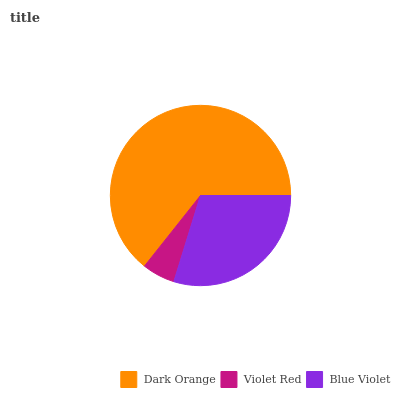Is Violet Red the minimum?
Answer yes or no. Yes. Is Dark Orange the maximum?
Answer yes or no. Yes. Is Blue Violet the minimum?
Answer yes or no. No. Is Blue Violet the maximum?
Answer yes or no. No. Is Blue Violet greater than Violet Red?
Answer yes or no. Yes. Is Violet Red less than Blue Violet?
Answer yes or no. Yes. Is Violet Red greater than Blue Violet?
Answer yes or no. No. Is Blue Violet less than Violet Red?
Answer yes or no. No. Is Blue Violet the high median?
Answer yes or no. Yes. Is Blue Violet the low median?
Answer yes or no. Yes. Is Violet Red the high median?
Answer yes or no. No. Is Violet Red the low median?
Answer yes or no. No. 